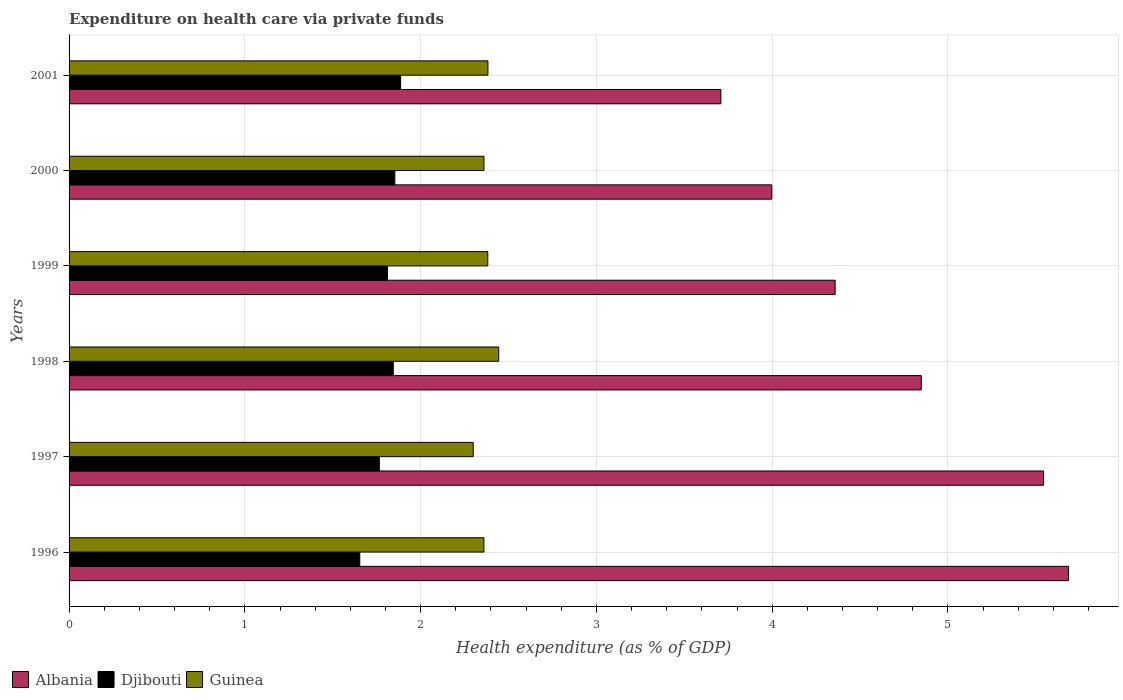How many different coloured bars are there?
Your response must be concise. 3. How many groups of bars are there?
Your response must be concise. 6. Are the number of bars per tick equal to the number of legend labels?
Give a very brief answer. Yes. What is the label of the 3rd group of bars from the top?
Ensure brevity in your answer.  1999. What is the expenditure made on health care in Djibouti in 2000?
Provide a succinct answer. 1.85. Across all years, what is the maximum expenditure made on health care in Djibouti?
Offer a terse response. 1.89. Across all years, what is the minimum expenditure made on health care in Guinea?
Your answer should be very brief. 2.3. In which year was the expenditure made on health care in Djibouti maximum?
Provide a short and direct response. 2001. In which year was the expenditure made on health care in Guinea minimum?
Offer a terse response. 1997. What is the total expenditure made on health care in Djibouti in the graph?
Give a very brief answer. 10.81. What is the difference between the expenditure made on health care in Djibouti in 1999 and that in 2000?
Offer a terse response. -0.04. What is the difference between the expenditure made on health care in Albania in 1996 and the expenditure made on health care in Guinea in 1997?
Your response must be concise. 3.39. What is the average expenditure made on health care in Albania per year?
Make the answer very short. 4.69. In the year 1999, what is the difference between the expenditure made on health care in Albania and expenditure made on health care in Djibouti?
Offer a very short reply. 2.55. In how many years, is the expenditure made on health care in Albania greater than 1.4 %?
Offer a very short reply. 6. What is the ratio of the expenditure made on health care in Guinea in 1997 to that in 1998?
Your answer should be compact. 0.94. What is the difference between the highest and the second highest expenditure made on health care in Djibouti?
Provide a succinct answer. 0.03. What is the difference between the highest and the lowest expenditure made on health care in Albania?
Ensure brevity in your answer.  1.98. What does the 1st bar from the top in 2001 represents?
Give a very brief answer. Guinea. What does the 2nd bar from the bottom in 1996 represents?
Provide a short and direct response. Djibouti. Is it the case that in every year, the sum of the expenditure made on health care in Guinea and expenditure made on health care in Djibouti is greater than the expenditure made on health care in Albania?
Make the answer very short. No. How many bars are there?
Your answer should be very brief. 18. Are the values on the major ticks of X-axis written in scientific E-notation?
Your answer should be compact. No. Does the graph contain any zero values?
Provide a short and direct response. No. Does the graph contain grids?
Your response must be concise. Yes. What is the title of the graph?
Ensure brevity in your answer.  Expenditure on health care via private funds. Does "Kyrgyz Republic" appear as one of the legend labels in the graph?
Make the answer very short. No. What is the label or title of the X-axis?
Keep it short and to the point. Health expenditure (as % of GDP). What is the label or title of the Y-axis?
Your answer should be very brief. Years. What is the Health expenditure (as % of GDP) in Albania in 1996?
Provide a short and direct response. 5.69. What is the Health expenditure (as % of GDP) in Djibouti in 1996?
Your response must be concise. 1.65. What is the Health expenditure (as % of GDP) of Guinea in 1996?
Make the answer very short. 2.36. What is the Health expenditure (as % of GDP) in Albania in 1997?
Your answer should be very brief. 5.54. What is the Health expenditure (as % of GDP) in Djibouti in 1997?
Your answer should be very brief. 1.77. What is the Health expenditure (as % of GDP) of Guinea in 1997?
Provide a short and direct response. 2.3. What is the Health expenditure (as % of GDP) in Albania in 1998?
Make the answer very short. 4.85. What is the Health expenditure (as % of GDP) in Djibouti in 1998?
Your answer should be very brief. 1.84. What is the Health expenditure (as % of GDP) of Guinea in 1998?
Offer a terse response. 2.44. What is the Health expenditure (as % of GDP) of Albania in 1999?
Provide a succinct answer. 4.36. What is the Health expenditure (as % of GDP) in Djibouti in 1999?
Provide a short and direct response. 1.81. What is the Health expenditure (as % of GDP) in Guinea in 1999?
Give a very brief answer. 2.38. What is the Health expenditure (as % of GDP) in Albania in 2000?
Provide a succinct answer. 4. What is the Health expenditure (as % of GDP) in Djibouti in 2000?
Your answer should be very brief. 1.85. What is the Health expenditure (as % of GDP) of Guinea in 2000?
Offer a very short reply. 2.36. What is the Health expenditure (as % of GDP) of Albania in 2001?
Keep it short and to the point. 3.71. What is the Health expenditure (as % of GDP) in Djibouti in 2001?
Ensure brevity in your answer.  1.89. What is the Health expenditure (as % of GDP) in Guinea in 2001?
Keep it short and to the point. 2.38. Across all years, what is the maximum Health expenditure (as % of GDP) in Albania?
Offer a terse response. 5.69. Across all years, what is the maximum Health expenditure (as % of GDP) of Djibouti?
Offer a terse response. 1.89. Across all years, what is the maximum Health expenditure (as % of GDP) in Guinea?
Your response must be concise. 2.44. Across all years, what is the minimum Health expenditure (as % of GDP) of Albania?
Your answer should be very brief. 3.71. Across all years, what is the minimum Health expenditure (as % of GDP) in Djibouti?
Provide a short and direct response. 1.65. Across all years, what is the minimum Health expenditure (as % of GDP) in Guinea?
Provide a succinct answer. 2.3. What is the total Health expenditure (as % of GDP) in Albania in the graph?
Ensure brevity in your answer.  28.14. What is the total Health expenditure (as % of GDP) in Djibouti in the graph?
Your answer should be very brief. 10.81. What is the total Health expenditure (as % of GDP) in Guinea in the graph?
Offer a terse response. 14.23. What is the difference between the Health expenditure (as % of GDP) in Albania in 1996 and that in 1997?
Your answer should be compact. 0.14. What is the difference between the Health expenditure (as % of GDP) in Djibouti in 1996 and that in 1997?
Your answer should be very brief. -0.11. What is the difference between the Health expenditure (as % of GDP) of Guinea in 1996 and that in 1997?
Ensure brevity in your answer.  0.06. What is the difference between the Health expenditure (as % of GDP) in Albania in 1996 and that in 1998?
Your answer should be very brief. 0.84. What is the difference between the Health expenditure (as % of GDP) of Djibouti in 1996 and that in 1998?
Offer a very short reply. -0.19. What is the difference between the Health expenditure (as % of GDP) of Guinea in 1996 and that in 1998?
Provide a succinct answer. -0.08. What is the difference between the Health expenditure (as % of GDP) of Albania in 1996 and that in 1999?
Ensure brevity in your answer.  1.33. What is the difference between the Health expenditure (as % of GDP) of Djibouti in 1996 and that in 1999?
Offer a very short reply. -0.16. What is the difference between the Health expenditure (as % of GDP) in Guinea in 1996 and that in 1999?
Your response must be concise. -0.02. What is the difference between the Health expenditure (as % of GDP) of Albania in 1996 and that in 2000?
Offer a terse response. 1.69. What is the difference between the Health expenditure (as % of GDP) in Djibouti in 1996 and that in 2000?
Keep it short and to the point. -0.2. What is the difference between the Health expenditure (as % of GDP) of Guinea in 1996 and that in 2000?
Make the answer very short. -0. What is the difference between the Health expenditure (as % of GDP) of Albania in 1996 and that in 2001?
Provide a succinct answer. 1.98. What is the difference between the Health expenditure (as % of GDP) of Djibouti in 1996 and that in 2001?
Provide a succinct answer. -0.23. What is the difference between the Health expenditure (as % of GDP) of Guinea in 1996 and that in 2001?
Give a very brief answer. -0.02. What is the difference between the Health expenditure (as % of GDP) in Albania in 1997 and that in 1998?
Offer a very short reply. 0.7. What is the difference between the Health expenditure (as % of GDP) of Djibouti in 1997 and that in 1998?
Ensure brevity in your answer.  -0.08. What is the difference between the Health expenditure (as % of GDP) in Guinea in 1997 and that in 1998?
Provide a short and direct response. -0.15. What is the difference between the Health expenditure (as % of GDP) of Albania in 1997 and that in 1999?
Ensure brevity in your answer.  1.19. What is the difference between the Health expenditure (as % of GDP) in Djibouti in 1997 and that in 1999?
Offer a terse response. -0.05. What is the difference between the Health expenditure (as % of GDP) in Guinea in 1997 and that in 1999?
Your answer should be very brief. -0.08. What is the difference between the Health expenditure (as % of GDP) in Albania in 1997 and that in 2000?
Your answer should be compact. 1.55. What is the difference between the Health expenditure (as % of GDP) of Djibouti in 1997 and that in 2000?
Offer a terse response. -0.09. What is the difference between the Health expenditure (as % of GDP) in Guinea in 1997 and that in 2000?
Your answer should be compact. -0.06. What is the difference between the Health expenditure (as % of GDP) of Albania in 1997 and that in 2001?
Your answer should be very brief. 1.84. What is the difference between the Health expenditure (as % of GDP) in Djibouti in 1997 and that in 2001?
Offer a very short reply. -0.12. What is the difference between the Health expenditure (as % of GDP) in Guinea in 1997 and that in 2001?
Your answer should be very brief. -0.08. What is the difference between the Health expenditure (as % of GDP) of Albania in 1998 and that in 1999?
Ensure brevity in your answer.  0.49. What is the difference between the Health expenditure (as % of GDP) of Djibouti in 1998 and that in 1999?
Offer a terse response. 0.03. What is the difference between the Health expenditure (as % of GDP) in Guinea in 1998 and that in 1999?
Provide a short and direct response. 0.06. What is the difference between the Health expenditure (as % of GDP) of Albania in 1998 and that in 2000?
Offer a very short reply. 0.85. What is the difference between the Health expenditure (as % of GDP) in Djibouti in 1998 and that in 2000?
Keep it short and to the point. -0.01. What is the difference between the Health expenditure (as % of GDP) in Guinea in 1998 and that in 2000?
Provide a succinct answer. 0.08. What is the difference between the Health expenditure (as % of GDP) of Albania in 1998 and that in 2001?
Ensure brevity in your answer.  1.14. What is the difference between the Health expenditure (as % of GDP) in Djibouti in 1998 and that in 2001?
Ensure brevity in your answer.  -0.04. What is the difference between the Health expenditure (as % of GDP) of Guinea in 1998 and that in 2001?
Make the answer very short. 0.06. What is the difference between the Health expenditure (as % of GDP) of Albania in 1999 and that in 2000?
Ensure brevity in your answer.  0.36. What is the difference between the Health expenditure (as % of GDP) of Djibouti in 1999 and that in 2000?
Make the answer very short. -0.04. What is the difference between the Health expenditure (as % of GDP) in Guinea in 1999 and that in 2000?
Provide a short and direct response. 0.02. What is the difference between the Health expenditure (as % of GDP) of Albania in 1999 and that in 2001?
Your response must be concise. 0.65. What is the difference between the Health expenditure (as % of GDP) in Djibouti in 1999 and that in 2001?
Make the answer very short. -0.07. What is the difference between the Health expenditure (as % of GDP) of Guinea in 1999 and that in 2001?
Ensure brevity in your answer.  -0. What is the difference between the Health expenditure (as % of GDP) in Albania in 2000 and that in 2001?
Your answer should be very brief. 0.29. What is the difference between the Health expenditure (as % of GDP) in Djibouti in 2000 and that in 2001?
Provide a succinct answer. -0.03. What is the difference between the Health expenditure (as % of GDP) of Guinea in 2000 and that in 2001?
Ensure brevity in your answer.  -0.02. What is the difference between the Health expenditure (as % of GDP) of Albania in 1996 and the Health expenditure (as % of GDP) of Djibouti in 1997?
Keep it short and to the point. 3.92. What is the difference between the Health expenditure (as % of GDP) in Albania in 1996 and the Health expenditure (as % of GDP) in Guinea in 1997?
Your response must be concise. 3.39. What is the difference between the Health expenditure (as % of GDP) in Djibouti in 1996 and the Health expenditure (as % of GDP) in Guinea in 1997?
Your answer should be compact. -0.65. What is the difference between the Health expenditure (as % of GDP) in Albania in 1996 and the Health expenditure (as % of GDP) in Djibouti in 1998?
Provide a short and direct response. 3.84. What is the difference between the Health expenditure (as % of GDP) in Albania in 1996 and the Health expenditure (as % of GDP) in Guinea in 1998?
Your answer should be very brief. 3.24. What is the difference between the Health expenditure (as % of GDP) in Djibouti in 1996 and the Health expenditure (as % of GDP) in Guinea in 1998?
Make the answer very short. -0.79. What is the difference between the Health expenditure (as % of GDP) of Albania in 1996 and the Health expenditure (as % of GDP) of Djibouti in 1999?
Your answer should be very brief. 3.87. What is the difference between the Health expenditure (as % of GDP) of Albania in 1996 and the Health expenditure (as % of GDP) of Guinea in 1999?
Provide a short and direct response. 3.3. What is the difference between the Health expenditure (as % of GDP) of Djibouti in 1996 and the Health expenditure (as % of GDP) of Guinea in 1999?
Give a very brief answer. -0.73. What is the difference between the Health expenditure (as % of GDP) of Albania in 1996 and the Health expenditure (as % of GDP) of Djibouti in 2000?
Your answer should be very brief. 3.83. What is the difference between the Health expenditure (as % of GDP) in Albania in 1996 and the Health expenditure (as % of GDP) in Guinea in 2000?
Your response must be concise. 3.33. What is the difference between the Health expenditure (as % of GDP) in Djibouti in 1996 and the Health expenditure (as % of GDP) in Guinea in 2000?
Make the answer very short. -0.71. What is the difference between the Health expenditure (as % of GDP) in Albania in 1996 and the Health expenditure (as % of GDP) in Djibouti in 2001?
Provide a succinct answer. 3.8. What is the difference between the Health expenditure (as % of GDP) in Albania in 1996 and the Health expenditure (as % of GDP) in Guinea in 2001?
Offer a very short reply. 3.3. What is the difference between the Health expenditure (as % of GDP) of Djibouti in 1996 and the Health expenditure (as % of GDP) of Guinea in 2001?
Offer a terse response. -0.73. What is the difference between the Health expenditure (as % of GDP) in Albania in 1997 and the Health expenditure (as % of GDP) in Djibouti in 1998?
Your answer should be very brief. 3.7. What is the difference between the Health expenditure (as % of GDP) in Albania in 1997 and the Health expenditure (as % of GDP) in Guinea in 1998?
Your answer should be compact. 3.1. What is the difference between the Health expenditure (as % of GDP) in Djibouti in 1997 and the Health expenditure (as % of GDP) in Guinea in 1998?
Provide a short and direct response. -0.68. What is the difference between the Health expenditure (as % of GDP) in Albania in 1997 and the Health expenditure (as % of GDP) in Djibouti in 1999?
Keep it short and to the point. 3.73. What is the difference between the Health expenditure (as % of GDP) of Albania in 1997 and the Health expenditure (as % of GDP) of Guinea in 1999?
Your answer should be compact. 3.16. What is the difference between the Health expenditure (as % of GDP) of Djibouti in 1997 and the Health expenditure (as % of GDP) of Guinea in 1999?
Ensure brevity in your answer.  -0.62. What is the difference between the Health expenditure (as % of GDP) in Albania in 1997 and the Health expenditure (as % of GDP) in Djibouti in 2000?
Make the answer very short. 3.69. What is the difference between the Health expenditure (as % of GDP) in Albania in 1997 and the Health expenditure (as % of GDP) in Guinea in 2000?
Make the answer very short. 3.18. What is the difference between the Health expenditure (as % of GDP) in Djibouti in 1997 and the Health expenditure (as % of GDP) in Guinea in 2000?
Make the answer very short. -0.59. What is the difference between the Health expenditure (as % of GDP) of Albania in 1997 and the Health expenditure (as % of GDP) of Djibouti in 2001?
Offer a terse response. 3.66. What is the difference between the Health expenditure (as % of GDP) in Albania in 1997 and the Health expenditure (as % of GDP) in Guinea in 2001?
Offer a very short reply. 3.16. What is the difference between the Health expenditure (as % of GDP) of Djibouti in 1997 and the Health expenditure (as % of GDP) of Guinea in 2001?
Keep it short and to the point. -0.62. What is the difference between the Health expenditure (as % of GDP) of Albania in 1998 and the Health expenditure (as % of GDP) of Djibouti in 1999?
Provide a short and direct response. 3.04. What is the difference between the Health expenditure (as % of GDP) of Albania in 1998 and the Health expenditure (as % of GDP) of Guinea in 1999?
Your response must be concise. 2.47. What is the difference between the Health expenditure (as % of GDP) of Djibouti in 1998 and the Health expenditure (as % of GDP) of Guinea in 1999?
Offer a very short reply. -0.54. What is the difference between the Health expenditure (as % of GDP) of Albania in 1998 and the Health expenditure (as % of GDP) of Djibouti in 2000?
Offer a very short reply. 2.99. What is the difference between the Health expenditure (as % of GDP) in Albania in 1998 and the Health expenditure (as % of GDP) in Guinea in 2000?
Give a very brief answer. 2.49. What is the difference between the Health expenditure (as % of GDP) of Djibouti in 1998 and the Health expenditure (as % of GDP) of Guinea in 2000?
Provide a short and direct response. -0.52. What is the difference between the Health expenditure (as % of GDP) of Albania in 1998 and the Health expenditure (as % of GDP) of Djibouti in 2001?
Offer a terse response. 2.96. What is the difference between the Health expenditure (as % of GDP) of Albania in 1998 and the Health expenditure (as % of GDP) of Guinea in 2001?
Make the answer very short. 2.47. What is the difference between the Health expenditure (as % of GDP) in Djibouti in 1998 and the Health expenditure (as % of GDP) in Guinea in 2001?
Your answer should be compact. -0.54. What is the difference between the Health expenditure (as % of GDP) in Albania in 1999 and the Health expenditure (as % of GDP) in Djibouti in 2000?
Your answer should be compact. 2.5. What is the difference between the Health expenditure (as % of GDP) in Albania in 1999 and the Health expenditure (as % of GDP) in Guinea in 2000?
Your response must be concise. 2. What is the difference between the Health expenditure (as % of GDP) of Djibouti in 1999 and the Health expenditure (as % of GDP) of Guinea in 2000?
Provide a succinct answer. -0.55. What is the difference between the Health expenditure (as % of GDP) of Albania in 1999 and the Health expenditure (as % of GDP) of Djibouti in 2001?
Your response must be concise. 2.47. What is the difference between the Health expenditure (as % of GDP) in Albania in 1999 and the Health expenditure (as % of GDP) in Guinea in 2001?
Your response must be concise. 1.98. What is the difference between the Health expenditure (as % of GDP) in Djibouti in 1999 and the Health expenditure (as % of GDP) in Guinea in 2001?
Provide a short and direct response. -0.57. What is the difference between the Health expenditure (as % of GDP) of Albania in 2000 and the Health expenditure (as % of GDP) of Djibouti in 2001?
Make the answer very short. 2.11. What is the difference between the Health expenditure (as % of GDP) of Albania in 2000 and the Health expenditure (as % of GDP) of Guinea in 2001?
Offer a terse response. 1.61. What is the difference between the Health expenditure (as % of GDP) of Djibouti in 2000 and the Health expenditure (as % of GDP) of Guinea in 2001?
Offer a terse response. -0.53. What is the average Health expenditure (as % of GDP) of Albania per year?
Provide a short and direct response. 4.69. What is the average Health expenditure (as % of GDP) in Djibouti per year?
Give a very brief answer. 1.8. What is the average Health expenditure (as % of GDP) of Guinea per year?
Keep it short and to the point. 2.37. In the year 1996, what is the difference between the Health expenditure (as % of GDP) in Albania and Health expenditure (as % of GDP) in Djibouti?
Keep it short and to the point. 4.03. In the year 1996, what is the difference between the Health expenditure (as % of GDP) in Albania and Health expenditure (as % of GDP) in Guinea?
Keep it short and to the point. 3.33. In the year 1996, what is the difference between the Health expenditure (as % of GDP) of Djibouti and Health expenditure (as % of GDP) of Guinea?
Offer a very short reply. -0.71. In the year 1997, what is the difference between the Health expenditure (as % of GDP) of Albania and Health expenditure (as % of GDP) of Djibouti?
Give a very brief answer. 3.78. In the year 1997, what is the difference between the Health expenditure (as % of GDP) in Albania and Health expenditure (as % of GDP) in Guinea?
Your answer should be very brief. 3.24. In the year 1997, what is the difference between the Health expenditure (as % of GDP) in Djibouti and Health expenditure (as % of GDP) in Guinea?
Provide a succinct answer. -0.53. In the year 1998, what is the difference between the Health expenditure (as % of GDP) of Albania and Health expenditure (as % of GDP) of Djibouti?
Ensure brevity in your answer.  3. In the year 1998, what is the difference between the Health expenditure (as % of GDP) in Albania and Health expenditure (as % of GDP) in Guinea?
Keep it short and to the point. 2.4. In the year 1998, what is the difference between the Health expenditure (as % of GDP) of Djibouti and Health expenditure (as % of GDP) of Guinea?
Provide a short and direct response. -0.6. In the year 1999, what is the difference between the Health expenditure (as % of GDP) of Albania and Health expenditure (as % of GDP) of Djibouti?
Offer a very short reply. 2.55. In the year 1999, what is the difference between the Health expenditure (as % of GDP) in Albania and Health expenditure (as % of GDP) in Guinea?
Your answer should be very brief. 1.98. In the year 1999, what is the difference between the Health expenditure (as % of GDP) of Djibouti and Health expenditure (as % of GDP) of Guinea?
Your response must be concise. -0.57. In the year 2000, what is the difference between the Health expenditure (as % of GDP) of Albania and Health expenditure (as % of GDP) of Djibouti?
Provide a succinct answer. 2.14. In the year 2000, what is the difference between the Health expenditure (as % of GDP) of Albania and Health expenditure (as % of GDP) of Guinea?
Ensure brevity in your answer.  1.64. In the year 2000, what is the difference between the Health expenditure (as % of GDP) of Djibouti and Health expenditure (as % of GDP) of Guinea?
Your answer should be compact. -0.51. In the year 2001, what is the difference between the Health expenditure (as % of GDP) in Albania and Health expenditure (as % of GDP) in Djibouti?
Ensure brevity in your answer.  1.82. In the year 2001, what is the difference between the Health expenditure (as % of GDP) in Albania and Health expenditure (as % of GDP) in Guinea?
Your answer should be very brief. 1.32. In the year 2001, what is the difference between the Health expenditure (as % of GDP) in Djibouti and Health expenditure (as % of GDP) in Guinea?
Provide a succinct answer. -0.5. What is the ratio of the Health expenditure (as % of GDP) in Albania in 1996 to that in 1997?
Your answer should be very brief. 1.03. What is the ratio of the Health expenditure (as % of GDP) of Djibouti in 1996 to that in 1997?
Offer a terse response. 0.94. What is the ratio of the Health expenditure (as % of GDP) in Guinea in 1996 to that in 1997?
Ensure brevity in your answer.  1.03. What is the ratio of the Health expenditure (as % of GDP) in Albania in 1996 to that in 1998?
Keep it short and to the point. 1.17. What is the ratio of the Health expenditure (as % of GDP) in Djibouti in 1996 to that in 1998?
Offer a very short reply. 0.9. What is the ratio of the Health expenditure (as % of GDP) of Guinea in 1996 to that in 1998?
Your answer should be compact. 0.97. What is the ratio of the Health expenditure (as % of GDP) in Albania in 1996 to that in 1999?
Provide a short and direct response. 1.3. What is the ratio of the Health expenditure (as % of GDP) of Djibouti in 1996 to that in 1999?
Ensure brevity in your answer.  0.91. What is the ratio of the Health expenditure (as % of GDP) of Albania in 1996 to that in 2000?
Keep it short and to the point. 1.42. What is the ratio of the Health expenditure (as % of GDP) of Djibouti in 1996 to that in 2000?
Offer a terse response. 0.89. What is the ratio of the Health expenditure (as % of GDP) in Albania in 1996 to that in 2001?
Your response must be concise. 1.53. What is the ratio of the Health expenditure (as % of GDP) of Djibouti in 1996 to that in 2001?
Ensure brevity in your answer.  0.88. What is the ratio of the Health expenditure (as % of GDP) in Albania in 1997 to that in 1998?
Offer a very short reply. 1.14. What is the ratio of the Health expenditure (as % of GDP) of Guinea in 1997 to that in 1998?
Provide a short and direct response. 0.94. What is the ratio of the Health expenditure (as % of GDP) of Albania in 1997 to that in 1999?
Provide a succinct answer. 1.27. What is the ratio of the Health expenditure (as % of GDP) of Djibouti in 1997 to that in 1999?
Offer a terse response. 0.97. What is the ratio of the Health expenditure (as % of GDP) in Guinea in 1997 to that in 1999?
Your answer should be very brief. 0.97. What is the ratio of the Health expenditure (as % of GDP) of Albania in 1997 to that in 2000?
Make the answer very short. 1.39. What is the ratio of the Health expenditure (as % of GDP) of Djibouti in 1997 to that in 2000?
Your answer should be very brief. 0.95. What is the ratio of the Health expenditure (as % of GDP) in Guinea in 1997 to that in 2000?
Your answer should be compact. 0.97. What is the ratio of the Health expenditure (as % of GDP) in Albania in 1997 to that in 2001?
Your answer should be very brief. 1.5. What is the ratio of the Health expenditure (as % of GDP) of Djibouti in 1997 to that in 2001?
Your answer should be compact. 0.94. What is the ratio of the Health expenditure (as % of GDP) in Guinea in 1997 to that in 2001?
Provide a short and direct response. 0.96. What is the ratio of the Health expenditure (as % of GDP) of Albania in 1998 to that in 1999?
Offer a very short reply. 1.11. What is the ratio of the Health expenditure (as % of GDP) in Djibouti in 1998 to that in 1999?
Provide a short and direct response. 1.02. What is the ratio of the Health expenditure (as % of GDP) in Guinea in 1998 to that in 1999?
Your response must be concise. 1.03. What is the ratio of the Health expenditure (as % of GDP) in Albania in 1998 to that in 2000?
Your answer should be compact. 1.21. What is the ratio of the Health expenditure (as % of GDP) of Djibouti in 1998 to that in 2000?
Provide a short and direct response. 1. What is the ratio of the Health expenditure (as % of GDP) of Guinea in 1998 to that in 2000?
Ensure brevity in your answer.  1.04. What is the ratio of the Health expenditure (as % of GDP) of Albania in 1998 to that in 2001?
Your response must be concise. 1.31. What is the ratio of the Health expenditure (as % of GDP) of Djibouti in 1998 to that in 2001?
Provide a short and direct response. 0.98. What is the ratio of the Health expenditure (as % of GDP) of Guinea in 1998 to that in 2001?
Offer a very short reply. 1.03. What is the ratio of the Health expenditure (as % of GDP) in Albania in 1999 to that in 2000?
Your response must be concise. 1.09. What is the ratio of the Health expenditure (as % of GDP) of Djibouti in 1999 to that in 2000?
Provide a succinct answer. 0.98. What is the ratio of the Health expenditure (as % of GDP) in Guinea in 1999 to that in 2000?
Offer a terse response. 1.01. What is the ratio of the Health expenditure (as % of GDP) in Albania in 1999 to that in 2001?
Offer a very short reply. 1.18. What is the ratio of the Health expenditure (as % of GDP) of Djibouti in 1999 to that in 2001?
Your answer should be compact. 0.96. What is the ratio of the Health expenditure (as % of GDP) in Albania in 2000 to that in 2001?
Make the answer very short. 1.08. What is the ratio of the Health expenditure (as % of GDP) of Djibouti in 2000 to that in 2001?
Ensure brevity in your answer.  0.98. What is the difference between the highest and the second highest Health expenditure (as % of GDP) of Albania?
Offer a very short reply. 0.14. What is the difference between the highest and the second highest Health expenditure (as % of GDP) of Djibouti?
Provide a short and direct response. 0.03. What is the difference between the highest and the second highest Health expenditure (as % of GDP) in Guinea?
Offer a very short reply. 0.06. What is the difference between the highest and the lowest Health expenditure (as % of GDP) of Albania?
Make the answer very short. 1.98. What is the difference between the highest and the lowest Health expenditure (as % of GDP) in Djibouti?
Your answer should be compact. 0.23. What is the difference between the highest and the lowest Health expenditure (as % of GDP) of Guinea?
Your answer should be very brief. 0.15. 